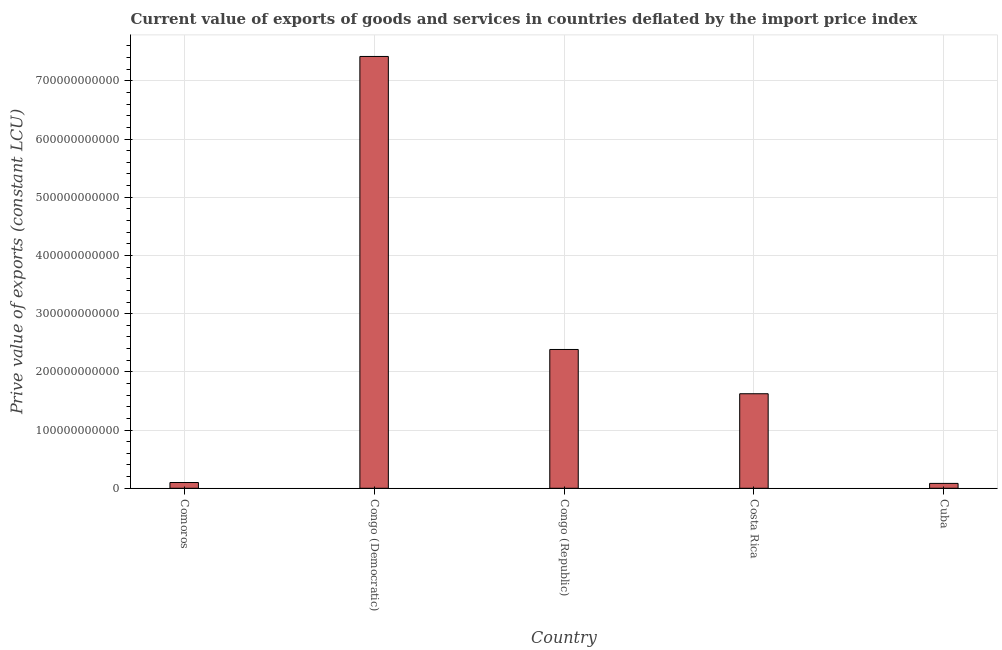Does the graph contain grids?
Your response must be concise. Yes. What is the title of the graph?
Offer a very short reply. Current value of exports of goods and services in countries deflated by the import price index. What is the label or title of the X-axis?
Provide a succinct answer. Country. What is the label or title of the Y-axis?
Give a very brief answer. Prive value of exports (constant LCU). What is the price value of exports in Costa Rica?
Offer a terse response. 1.62e+11. Across all countries, what is the maximum price value of exports?
Give a very brief answer. 7.42e+11. Across all countries, what is the minimum price value of exports?
Provide a short and direct response. 8.39e+09. In which country was the price value of exports maximum?
Make the answer very short. Congo (Democratic). In which country was the price value of exports minimum?
Your answer should be compact. Cuba. What is the sum of the price value of exports?
Make the answer very short. 1.16e+12. What is the difference between the price value of exports in Comoros and Congo (Democratic)?
Ensure brevity in your answer.  -7.32e+11. What is the average price value of exports per country?
Offer a very short reply. 2.32e+11. What is the median price value of exports?
Give a very brief answer. 1.62e+11. What is the ratio of the price value of exports in Congo (Republic) to that in Costa Rica?
Your answer should be very brief. 1.47. Is the difference between the price value of exports in Comoros and Congo (Democratic) greater than the difference between any two countries?
Ensure brevity in your answer.  No. What is the difference between the highest and the second highest price value of exports?
Offer a terse response. 5.03e+11. Is the sum of the price value of exports in Congo (Democratic) and Congo (Republic) greater than the maximum price value of exports across all countries?
Provide a succinct answer. Yes. What is the difference between the highest and the lowest price value of exports?
Your answer should be very brief. 7.34e+11. How many bars are there?
Offer a very short reply. 5. Are all the bars in the graph horizontal?
Provide a short and direct response. No. How many countries are there in the graph?
Provide a succinct answer. 5. What is the difference between two consecutive major ticks on the Y-axis?
Offer a terse response. 1.00e+11. Are the values on the major ticks of Y-axis written in scientific E-notation?
Your answer should be very brief. No. What is the Prive value of exports (constant LCU) of Comoros?
Your answer should be very brief. 9.93e+09. What is the Prive value of exports (constant LCU) of Congo (Democratic)?
Your answer should be compact. 7.42e+11. What is the Prive value of exports (constant LCU) of Congo (Republic)?
Your answer should be very brief. 2.38e+11. What is the Prive value of exports (constant LCU) of Costa Rica?
Give a very brief answer. 1.62e+11. What is the Prive value of exports (constant LCU) in Cuba?
Provide a short and direct response. 8.39e+09. What is the difference between the Prive value of exports (constant LCU) in Comoros and Congo (Democratic)?
Keep it short and to the point. -7.32e+11. What is the difference between the Prive value of exports (constant LCU) in Comoros and Congo (Republic)?
Your response must be concise. -2.29e+11. What is the difference between the Prive value of exports (constant LCU) in Comoros and Costa Rica?
Provide a short and direct response. -1.53e+11. What is the difference between the Prive value of exports (constant LCU) in Comoros and Cuba?
Your answer should be compact. 1.54e+09. What is the difference between the Prive value of exports (constant LCU) in Congo (Democratic) and Congo (Republic)?
Your answer should be very brief. 5.03e+11. What is the difference between the Prive value of exports (constant LCU) in Congo (Democratic) and Costa Rica?
Your answer should be very brief. 5.79e+11. What is the difference between the Prive value of exports (constant LCU) in Congo (Democratic) and Cuba?
Your answer should be compact. 7.34e+11. What is the difference between the Prive value of exports (constant LCU) in Congo (Republic) and Costa Rica?
Keep it short and to the point. 7.61e+1. What is the difference between the Prive value of exports (constant LCU) in Congo (Republic) and Cuba?
Your response must be concise. 2.30e+11. What is the difference between the Prive value of exports (constant LCU) in Costa Rica and Cuba?
Offer a terse response. 1.54e+11. What is the ratio of the Prive value of exports (constant LCU) in Comoros to that in Congo (Democratic)?
Provide a short and direct response. 0.01. What is the ratio of the Prive value of exports (constant LCU) in Comoros to that in Congo (Republic)?
Your response must be concise. 0.04. What is the ratio of the Prive value of exports (constant LCU) in Comoros to that in Costa Rica?
Provide a short and direct response. 0.06. What is the ratio of the Prive value of exports (constant LCU) in Comoros to that in Cuba?
Ensure brevity in your answer.  1.18. What is the ratio of the Prive value of exports (constant LCU) in Congo (Democratic) to that in Congo (Republic)?
Your answer should be compact. 3.11. What is the ratio of the Prive value of exports (constant LCU) in Congo (Democratic) to that in Costa Rica?
Give a very brief answer. 4.57. What is the ratio of the Prive value of exports (constant LCU) in Congo (Democratic) to that in Cuba?
Your answer should be compact. 88.47. What is the ratio of the Prive value of exports (constant LCU) in Congo (Republic) to that in Costa Rica?
Provide a short and direct response. 1.47. What is the ratio of the Prive value of exports (constant LCU) in Congo (Republic) to that in Cuba?
Offer a very short reply. 28.44. What is the ratio of the Prive value of exports (constant LCU) in Costa Rica to that in Cuba?
Your response must be concise. 19.37. 